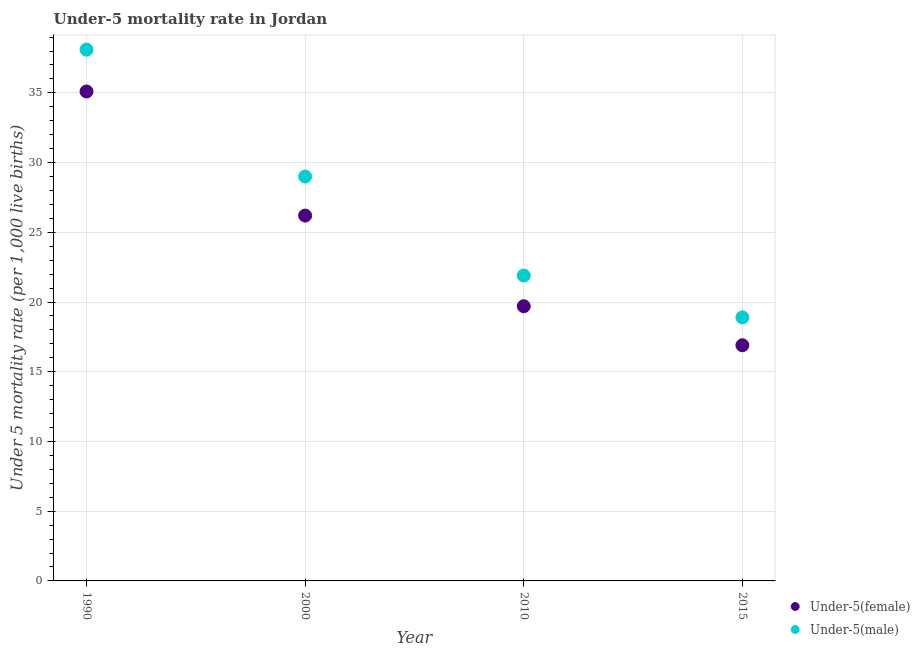What is the under-5 female mortality rate in 1990?
Your answer should be compact. 35.1. Across all years, what is the maximum under-5 female mortality rate?
Your answer should be compact. 35.1. Across all years, what is the minimum under-5 female mortality rate?
Your answer should be compact. 16.9. In which year was the under-5 female mortality rate minimum?
Ensure brevity in your answer.  2015. What is the total under-5 male mortality rate in the graph?
Your answer should be compact. 107.9. What is the difference between the under-5 male mortality rate in 1990 and that in 2000?
Ensure brevity in your answer.  9.1. What is the difference between the under-5 male mortality rate in 1990 and the under-5 female mortality rate in 2000?
Your answer should be very brief. 11.9. What is the average under-5 female mortality rate per year?
Offer a terse response. 24.48. In the year 2000, what is the difference between the under-5 male mortality rate and under-5 female mortality rate?
Keep it short and to the point. 2.8. In how many years, is the under-5 female mortality rate greater than 10?
Your response must be concise. 4. What is the ratio of the under-5 female mortality rate in 1990 to that in 2015?
Offer a very short reply. 2.08. Is the under-5 female mortality rate in 1990 less than that in 2010?
Keep it short and to the point. No. Is the difference between the under-5 female mortality rate in 1990 and 2015 greater than the difference between the under-5 male mortality rate in 1990 and 2015?
Offer a very short reply. No. What is the difference between the highest and the second highest under-5 female mortality rate?
Give a very brief answer. 8.9. What is the difference between the highest and the lowest under-5 male mortality rate?
Give a very brief answer. 19.2. Is the sum of the under-5 male mortality rate in 2000 and 2015 greater than the maximum under-5 female mortality rate across all years?
Your response must be concise. Yes. Are the values on the major ticks of Y-axis written in scientific E-notation?
Ensure brevity in your answer.  No. Does the graph contain any zero values?
Ensure brevity in your answer.  No. Does the graph contain grids?
Ensure brevity in your answer.  Yes. How many legend labels are there?
Provide a succinct answer. 2. What is the title of the graph?
Ensure brevity in your answer.  Under-5 mortality rate in Jordan. Does "Lower secondary rate" appear as one of the legend labels in the graph?
Your answer should be very brief. No. What is the label or title of the X-axis?
Make the answer very short. Year. What is the label or title of the Y-axis?
Offer a very short reply. Under 5 mortality rate (per 1,0 live births). What is the Under 5 mortality rate (per 1,000 live births) in Under-5(female) in 1990?
Provide a succinct answer. 35.1. What is the Under 5 mortality rate (per 1,000 live births) of Under-5(male) in 1990?
Provide a succinct answer. 38.1. What is the Under 5 mortality rate (per 1,000 live births) in Under-5(female) in 2000?
Provide a succinct answer. 26.2. What is the Under 5 mortality rate (per 1,000 live births) in Under-5(female) in 2010?
Your answer should be compact. 19.7. What is the Under 5 mortality rate (per 1,000 live births) of Under-5(male) in 2010?
Keep it short and to the point. 21.9. Across all years, what is the maximum Under 5 mortality rate (per 1,000 live births) in Under-5(female)?
Your answer should be compact. 35.1. Across all years, what is the maximum Under 5 mortality rate (per 1,000 live births) in Under-5(male)?
Your answer should be very brief. 38.1. What is the total Under 5 mortality rate (per 1,000 live births) of Under-5(female) in the graph?
Give a very brief answer. 97.9. What is the total Under 5 mortality rate (per 1,000 live births) in Under-5(male) in the graph?
Your answer should be very brief. 107.9. What is the difference between the Under 5 mortality rate (per 1,000 live births) in Under-5(female) in 1990 and that in 2000?
Offer a very short reply. 8.9. What is the difference between the Under 5 mortality rate (per 1,000 live births) of Under-5(female) in 1990 and that in 2010?
Provide a succinct answer. 15.4. What is the difference between the Under 5 mortality rate (per 1,000 live births) in Under-5(female) in 1990 and that in 2015?
Make the answer very short. 18.2. What is the difference between the Under 5 mortality rate (per 1,000 live births) in Under-5(male) in 1990 and that in 2015?
Offer a very short reply. 19.2. What is the difference between the Under 5 mortality rate (per 1,000 live births) in Under-5(female) in 2000 and that in 2010?
Offer a terse response. 6.5. What is the difference between the Under 5 mortality rate (per 1,000 live births) of Under-5(male) in 2000 and that in 2010?
Your answer should be very brief. 7.1. What is the difference between the Under 5 mortality rate (per 1,000 live births) of Under-5(female) in 2000 and that in 2015?
Offer a very short reply. 9.3. What is the difference between the Under 5 mortality rate (per 1,000 live births) of Under-5(male) in 2000 and that in 2015?
Provide a succinct answer. 10.1. What is the difference between the Under 5 mortality rate (per 1,000 live births) in Under-5(female) in 2010 and that in 2015?
Your answer should be very brief. 2.8. What is the difference between the Under 5 mortality rate (per 1,000 live births) of Under-5(male) in 2010 and that in 2015?
Offer a terse response. 3. What is the difference between the Under 5 mortality rate (per 1,000 live births) of Under-5(female) in 1990 and the Under 5 mortality rate (per 1,000 live births) of Under-5(male) in 2015?
Give a very brief answer. 16.2. What is the difference between the Under 5 mortality rate (per 1,000 live births) of Under-5(female) in 2000 and the Under 5 mortality rate (per 1,000 live births) of Under-5(male) in 2015?
Offer a terse response. 7.3. What is the difference between the Under 5 mortality rate (per 1,000 live births) of Under-5(female) in 2010 and the Under 5 mortality rate (per 1,000 live births) of Under-5(male) in 2015?
Keep it short and to the point. 0.8. What is the average Under 5 mortality rate (per 1,000 live births) of Under-5(female) per year?
Make the answer very short. 24.48. What is the average Under 5 mortality rate (per 1,000 live births) in Under-5(male) per year?
Keep it short and to the point. 26.98. In the year 1990, what is the difference between the Under 5 mortality rate (per 1,000 live births) in Under-5(female) and Under 5 mortality rate (per 1,000 live births) in Under-5(male)?
Your answer should be very brief. -3. In the year 2010, what is the difference between the Under 5 mortality rate (per 1,000 live births) of Under-5(female) and Under 5 mortality rate (per 1,000 live births) of Under-5(male)?
Your answer should be compact. -2.2. In the year 2015, what is the difference between the Under 5 mortality rate (per 1,000 live births) in Under-5(female) and Under 5 mortality rate (per 1,000 live births) in Under-5(male)?
Offer a terse response. -2. What is the ratio of the Under 5 mortality rate (per 1,000 live births) in Under-5(female) in 1990 to that in 2000?
Ensure brevity in your answer.  1.34. What is the ratio of the Under 5 mortality rate (per 1,000 live births) in Under-5(male) in 1990 to that in 2000?
Your answer should be compact. 1.31. What is the ratio of the Under 5 mortality rate (per 1,000 live births) of Under-5(female) in 1990 to that in 2010?
Offer a terse response. 1.78. What is the ratio of the Under 5 mortality rate (per 1,000 live births) of Under-5(male) in 1990 to that in 2010?
Make the answer very short. 1.74. What is the ratio of the Under 5 mortality rate (per 1,000 live births) of Under-5(female) in 1990 to that in 2015?
Keep it short and to the point. 2.08. What is the ratio of the Under 5 mortality rate (per 1,000 live births) of Under-5(male) in 1990 to that in 2015?
Provide a succinct answer. 2.02. What is the ratio of the Under 5 mortality rate (per 1,000 live births) of Under-5(female) in 2000 to that in 2010?
Offer a terse response. 1.33. What is the ratio of the Under 5 mortality rate (per 1,000 live births) in Under-5(male) in 2000 to that in 2010?
Offer a terse response. 1.32. What is the ratio of the Under 5 mortality rate (per 1,000 live births) in Under-5(female) in 2000 to that in 2015?
Give a very brief answer. 1.55. What is the ratio of the Under 5 mortality rate (per 1,000 live births) of Under-5(male) in 2000 to that in 2015?
Provide a succinct answer. 1.53. What is the ratio of the Under 5 mortality rate (per 1,000 live births) in Under-5(female) in 2010 to that in 2015?
Provide a succinct answer. 1.17. What is the ratio of the Under 5 mortality rate (per 1,000 live births) in Under-5(male) in 2010 to that in 2015?
Give a very brief answer. 1.16. What is the difference between the highest and the second highest Under 5 mortality rate (per 1,000 live births) in Under-5(female)?
Make the answer very short. 8.9. What is the difference between the highest and the lowest Under 5 mortality rate (per 1,000 live births) of Under-5(male)?
Offer a very short reply. 19.2. 